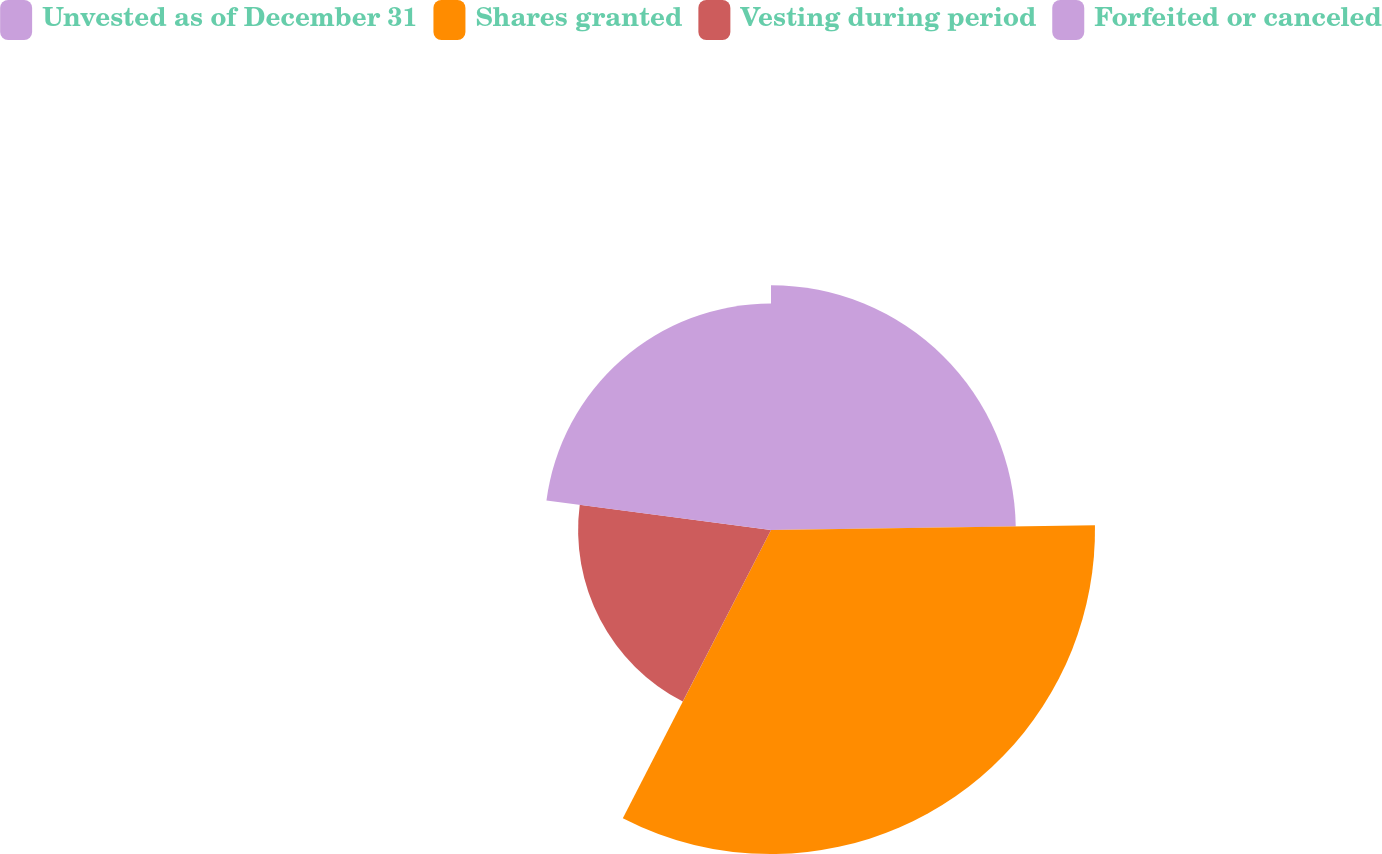Convert chart to OTSL. <chart><loc_0><loc_0><loc_500><loc_500><pie_chart><fcel>Unvested as of December 31<fcel>Shares granted<fcel>Vesting during period<fcel>Forfeited or canceled<nl><fcel>24.77%<fcel>32.79%<fcel>19.52%<fcel>22.92%<nl></chart> 